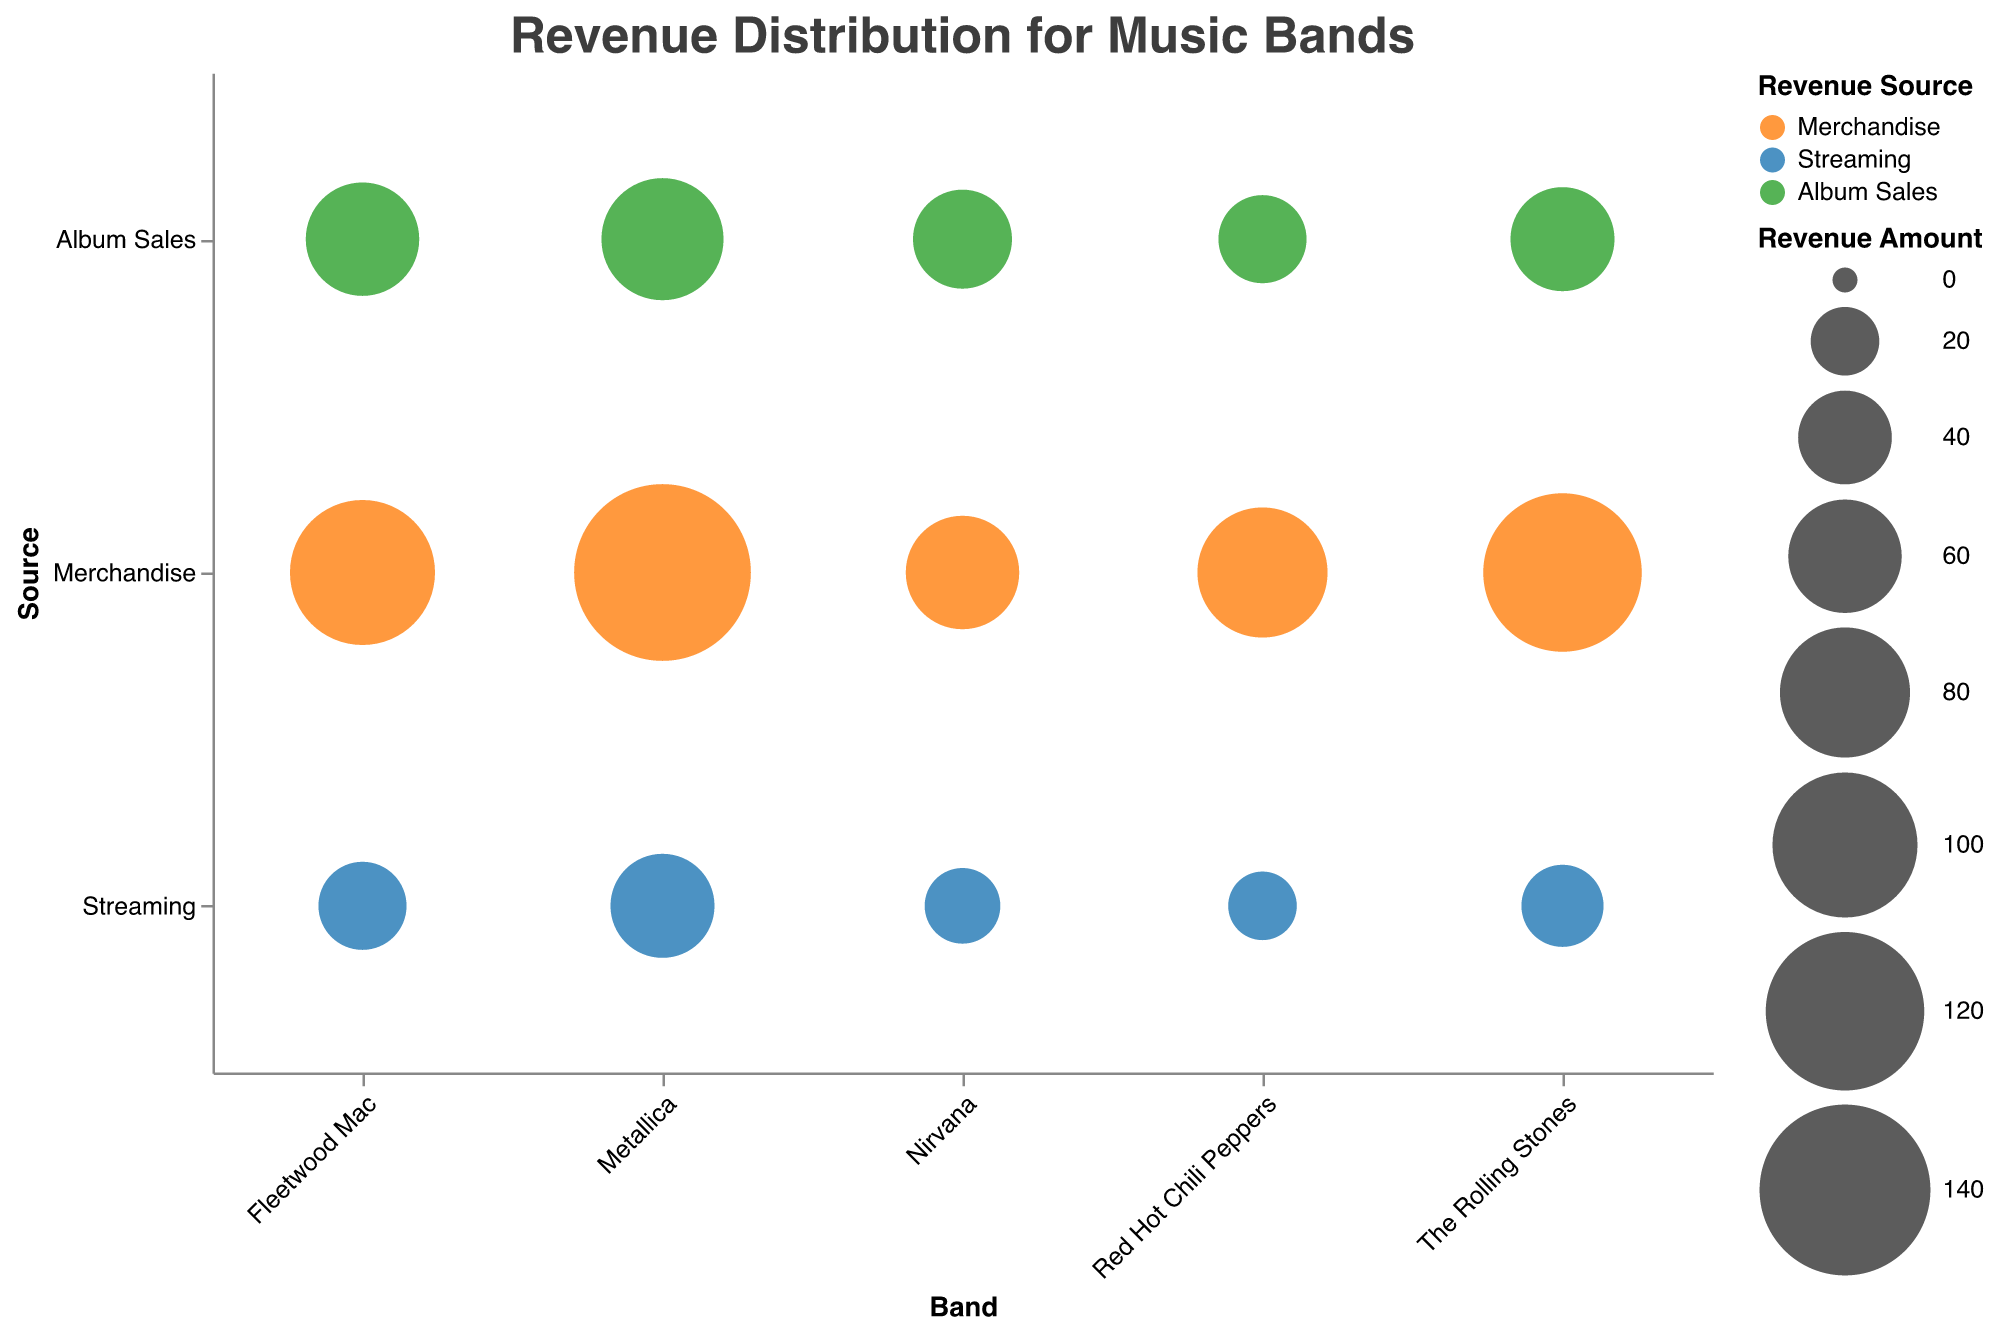What is the title of the chart? The title is prominently displayed at the top of the chart. It reads "Revenue Distribution for Music Bands." This title provides a clear indication of what the chart is representing.
Answer: Revenue Distribution for Music Bands Which band has the largest revenue from merchandise? To find this, look for the largest bubble in the "Merchandise" row. The largest bubble in this row corresponds to Metallica with a revenue of 15,000,000.
Answer: Metallica Compare the album sales revenue of The Rolling Stones and Metallica. Which band has higher album sales revenue? Locate the album sales bubbles for The Rolling Stones and Metallica. The Rolling Stones have a revenue of 5,000,000 from album sales, while Metallica has 7,000,000. Therefore, Metallica has higher album sales revenue.
Answer: Metallica What is the Total revenue from streaming for all bands combined? Sum the revenue from the streaming bubbles for all bands: The Rolling Stones (3,000,000) + Red Hot Chili Peppers (2,000,000) + Metallica (5,000,000) + Nirvana (2,500,000) + Fleetwood Mac (3,500,000). This totals to 16,000,000.
Answer: 16,000,000 Which revenue source contributes the most for Fleetwood Mac? Look at the three bubbles corresponding to Fleetwood Mac (Merchandise, Streaming, and Album Sales) and check their sizes. The largest bubble is for Merchandise with a revenue of 10,000,000.
Answer: Merchandise Compare the streaming revenues of Nirvana and Red Hot Chili Peppers. Which band has lower streaming revenue? Locate the streaming bubbles for Nirvana and Red Hot Chili Peppers. Nirvana has 2,500,000, and Red Hot Chili Peppers have 2,000,000 in streaming revenue. Therefore, Red Hot Chili Peppers have lower streaming revenue.
Answer: Red Hot Chili Peppers Rank the bands based on their total revenue from highest to lowest. Add each band's revenues from merchandise, streaming, and album sales:  
- Metallica: 15,000,000 + 5,000,000 + 7,000,000 = 27,000,000  
- The Rolling Stones: 12,000,000 + 3,000,000 + 5,000,000 = 20,000,000  
- Fleetwood Mac: 10,000,000 + 3,500,000 + 6,000,000 = 19,500,000  
- Red Hot Chili Peppers: 8,000,000 + 2,000,000 + 3,500,000 = 13,500,000  
- Nirvana: 6,000,000 + 2,500,000 + 4,500,000 = 13,000,000  
The ranking is: Metallica, The Rolling Stones, Fleetwood Mac, Red Hot Chili Peppers, Nirvana.
Answer: Metallica, The Rolling Stones, Fleetwood Mac, Red Hot Chili Peppers, Nirvana Which band has the smallest revenue source, and what is it? Look for the smallest bubble across all bands and sources. The smallest bubble is for Red Hot Chili Peppers' streaming revenue, which is 2,000,000.
Answer: Red Hot Chili Peppers, Streaming What percentage of Metallica's total revenue comes from merchandise? Metallica's total revenue is 15,000,000 (Merchandise) + 5,000,000 (Streaming) + 7,000,000 (Album Sales) = 27,000,000. The percentage of revenue from merchandise is (15,000,000 / 27,000,000) * 100 ≈ 55.56%.
Answer: 55.56% Compare the total album sales revenue of Fleetwood Mac and Nirvana. What is the difference? Fleetwood Mac's album sales revenue is 6,000,000 and Nirvana's is 4,500,000. The difference is 6,000,000 - 4,500,000 = 1,500,000.
Answer: 1,500,000 